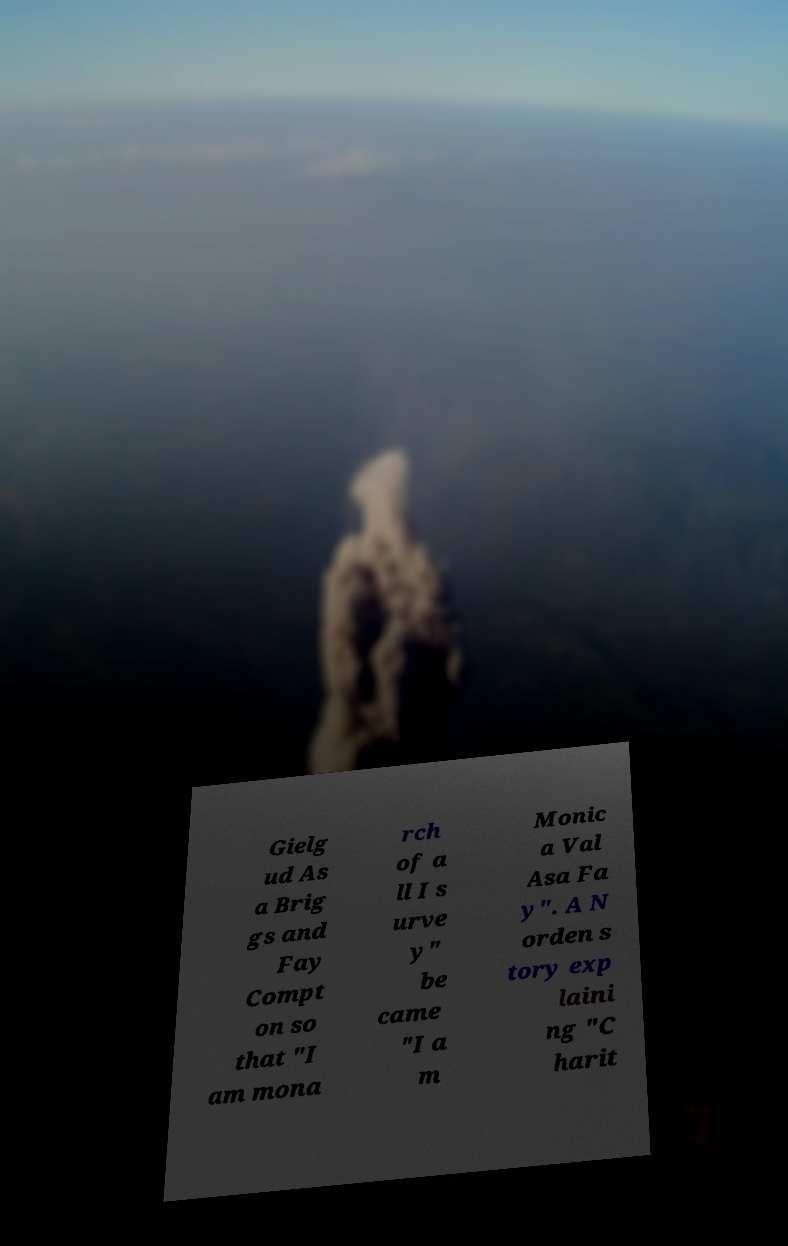Can you read and provide the text displayed in the image?This photo seems to have some interesting text. Can you extract and type it out for me? Gielg ud As a Brig gs and Fay Compt on so that "I am mona rch of a ll I s urve y" be came "I a m Monic a Val Asa Fa y". A N orden s tory exp laini ng "C harit 